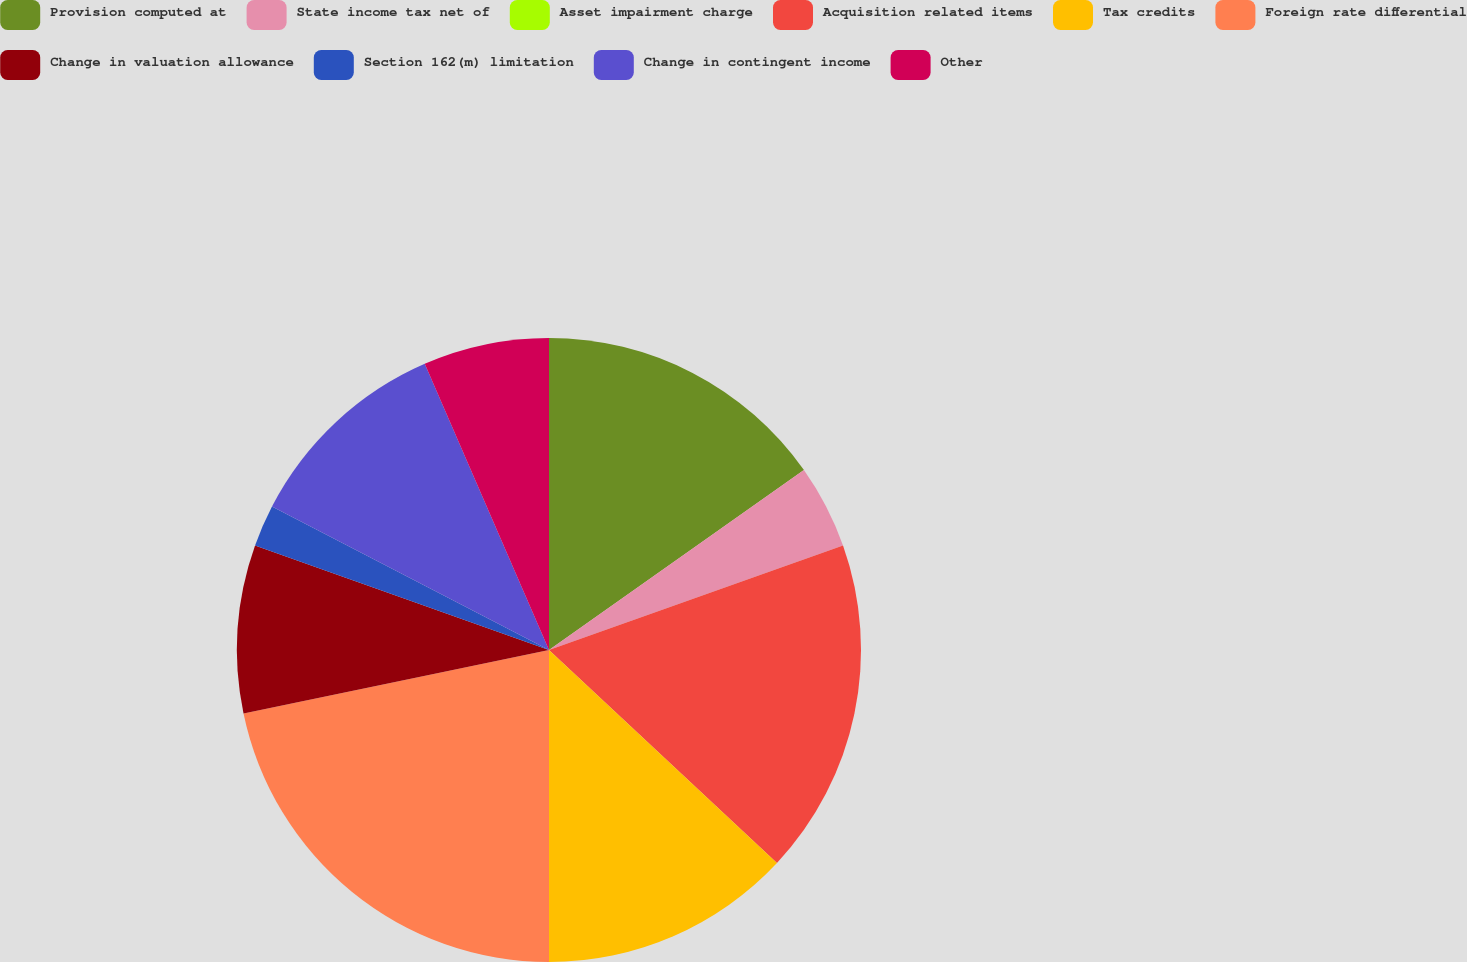Convert chart. <chart><loc_0><loc_0><loc_500><loc_500><pie_chart><fcel>Provision computed at<fcel>State income tax net of<fcel>Asset impairment charge<fcel>Acquisition related items<fcel>Tax credits<fcel>Foreign rate differential<fcel>Change in valuation allowance<fcel>Section 162(m) limitation<fcel>Change in contingent income<fcel>Other<nl><fcel>15.22%<fcel>4.35%<fcel>0.0%<fcel>17.39%<fcel>13.04%<fcel>21.74%<fcel>8.7%<fcel>2.17%<fcel>10.87%<fcel>6.52%<nl></chart> 